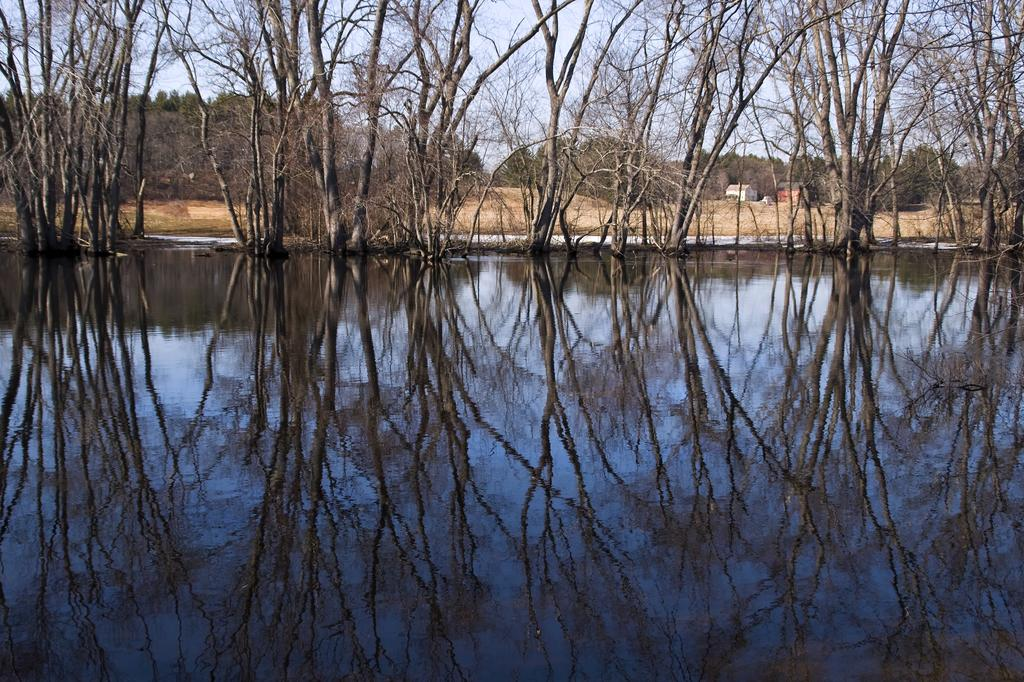What can be seen reflecting on the water surface in the image? There is a reflection of trees on the water surface in the image. What type of structures can be seen in the image? There are buildings visible in the image. What type of vegetation is present in the image? There are trees present in the image. What is visible above the water and buildings in the image? The sky is visible in the image. What type of camera can be seen in the image? There is no camera present in the image. What color is the paint on the trees in the image? There is no paint on the trees in the image; they are natural trees. 